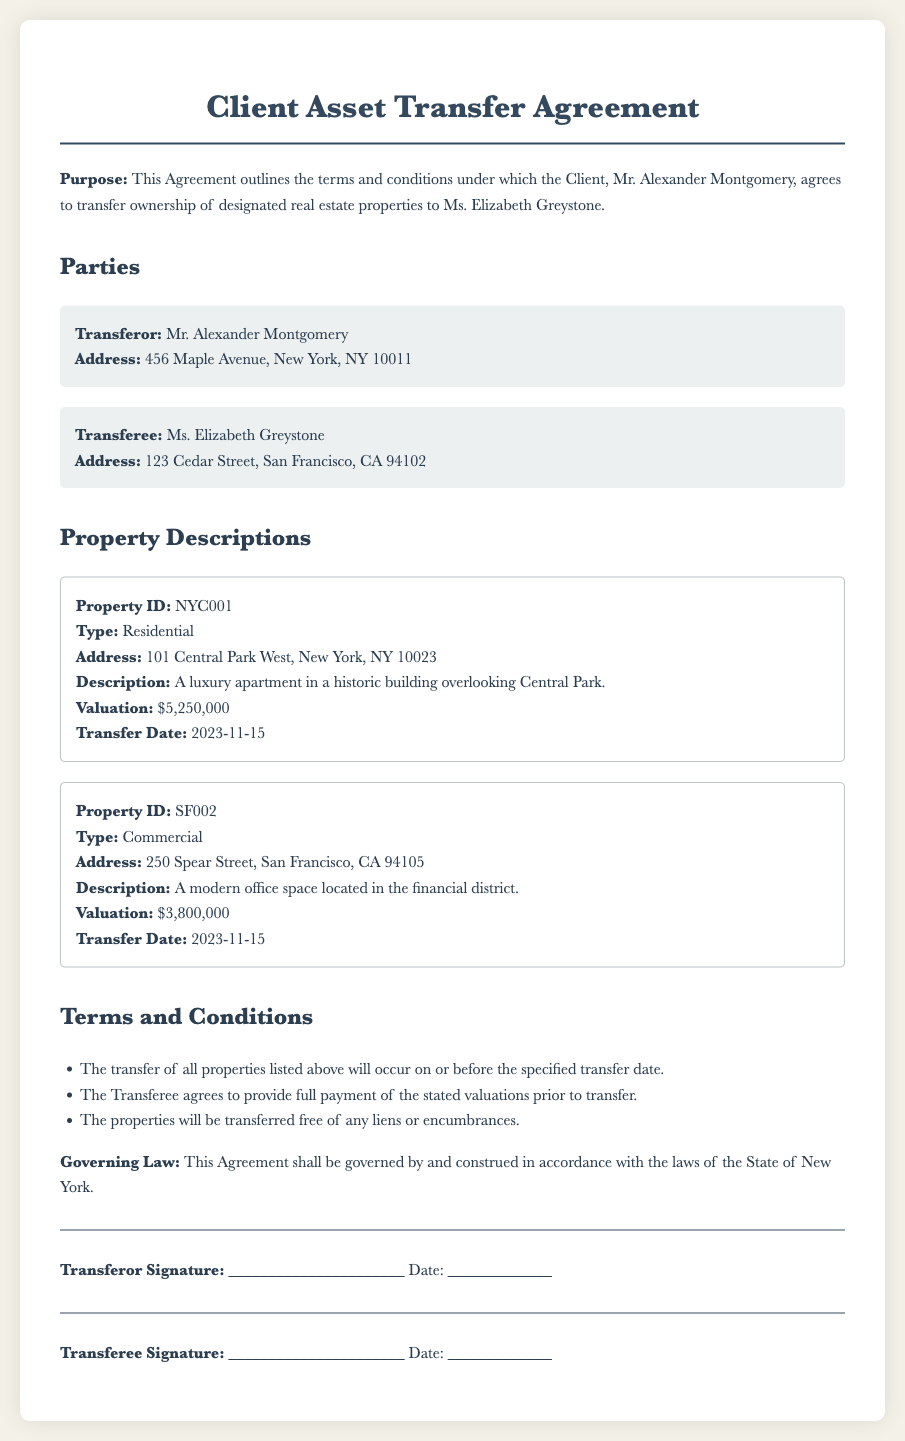What is the name of the transferor? The transferor is named in the document as Mr. Alexander Montgomery.
Answer: Mr. Alexander Montgomery What is the address of the transferee? The address of the transferee is provided in the document as 123 Cedar Street, San Francisco, CA 94102.
Answer: 123 Cedar Street, San Francisco, CA 94102 What is the valuation of the residential property? The valuation is stated in the document as $5,250,000 for the residential property.
Answer: $5,250,000 On what date is the property transfer scheduled? The transfer date for both properties is specified as 2023-11-15 in the document.
Answer: 2023-11-15 How many properties are included in the agreement? The document lists a total of two properties under the property descriptions section.
Answer: Two properties What type of property is located at 101 Central Park West? The document classifies this property as residential.
Answer: Residential What is the governing law stated in the agreement? The governing law according to the document is that of the State of New York.
Answer: State of New York What type of property is 250 Spear Street? The type of property at this address is noted as commercial in the document.
Answer: Commercial What is the transferor required to provide before the transfer? According to the terms, the transferor must provide full payment prior to the transfer.
Answer: Full payment 